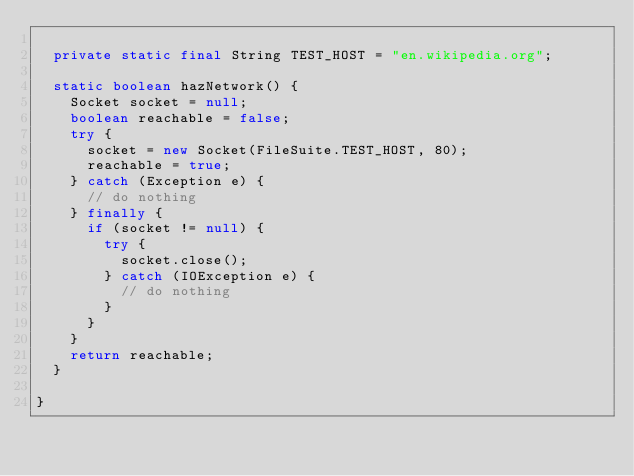<code> <loc_0><loc_0><loc_500><loc_500><_Java_>
  private static final String TEST_HOST = "en.wikipedia.org";

  static boolean hazNetwork() {
    Socket socket = null;
    boolean reachable = false;
    try {
      socket = new Socket(FileSuite.TEST_HOST, 80);
      reachable = true;
    } catch (Exception e) {
      // do nothing
    } finally {
      if (socket != null) {
        try {
          socket.close();
        } catch (IOException e) {
          // do nothing
        }
      }
    }
    return reachable;
  }

}
</code> 